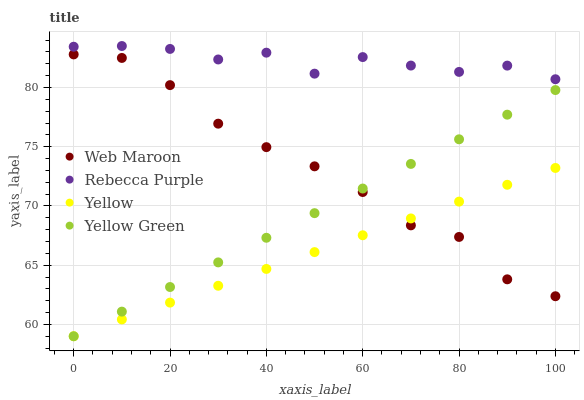Does Yellow have the minimum area under the curve?
Answer yes or no. Yes. Does Rebecca Purple have the maximum area under the curve?
Answer yes or no. Yes. Does Rebecca Purple have the minimum area under the curve?
Answer yes or no. No. Does Yellow have the maximum area under the curve?
Answer yes or no. No. Is Yellow Green the smoothest?
Answer yes or no. Yes. Is Rebecca Purple the roughest?
Answer yes or no. Yes. Is Yellow the smoothest?
Answer yes or no. No. Is Yellow the roughest?
Answer yes or no. No. Does Yellow have the lowest value?
Answer yes or no. Yes. Does Rebecca Purple have the lowest value?
Answer yes or no. No. Does Rebecca Purple have the highest value?
Answer yes or no. Yes. Does Yellow have the highest value?
Answer yes or no. No. Is Yellow Green less than Rebecca Purple?
Answer yes or no. Yes. Is Rebecca Purple greater than Web Maroon?
Answer yes or no. Yes. Does Yellow intersect Yellow Green?
Answer yes or no. Yes. Is Yellow less than Yellow Green?
Answer yes or no. No. Is Yellow greater than Yellow Green?
Answer yes or no. No. Does Yellow Green intersect Rebecca Purple?
Answer yes or no. No. 